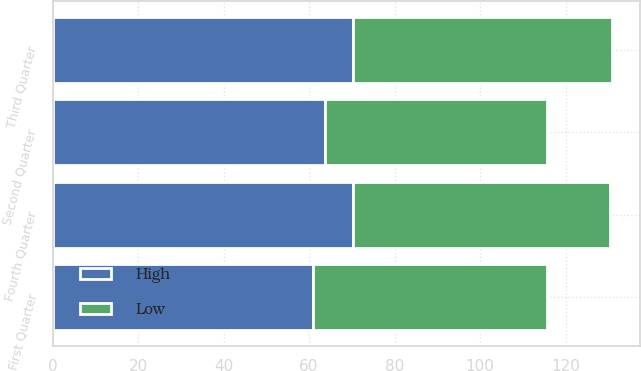<chart> <loc_0><loc_0><loc_500><loc_500><stacked_bar_chart><ecel><fcel>Fourth Quarter<fcel>Third Quarter<fcel>Second Quarter<fcel>First Quarter<nl><fcel>High<fcel>70.25<fcel>70.18<fcel>63.85<fcel>60.84<nl><fcel>Low<fcel>60.1<fcel>60.6<fcel>51.86<fcel>54.78<nl></chart> 